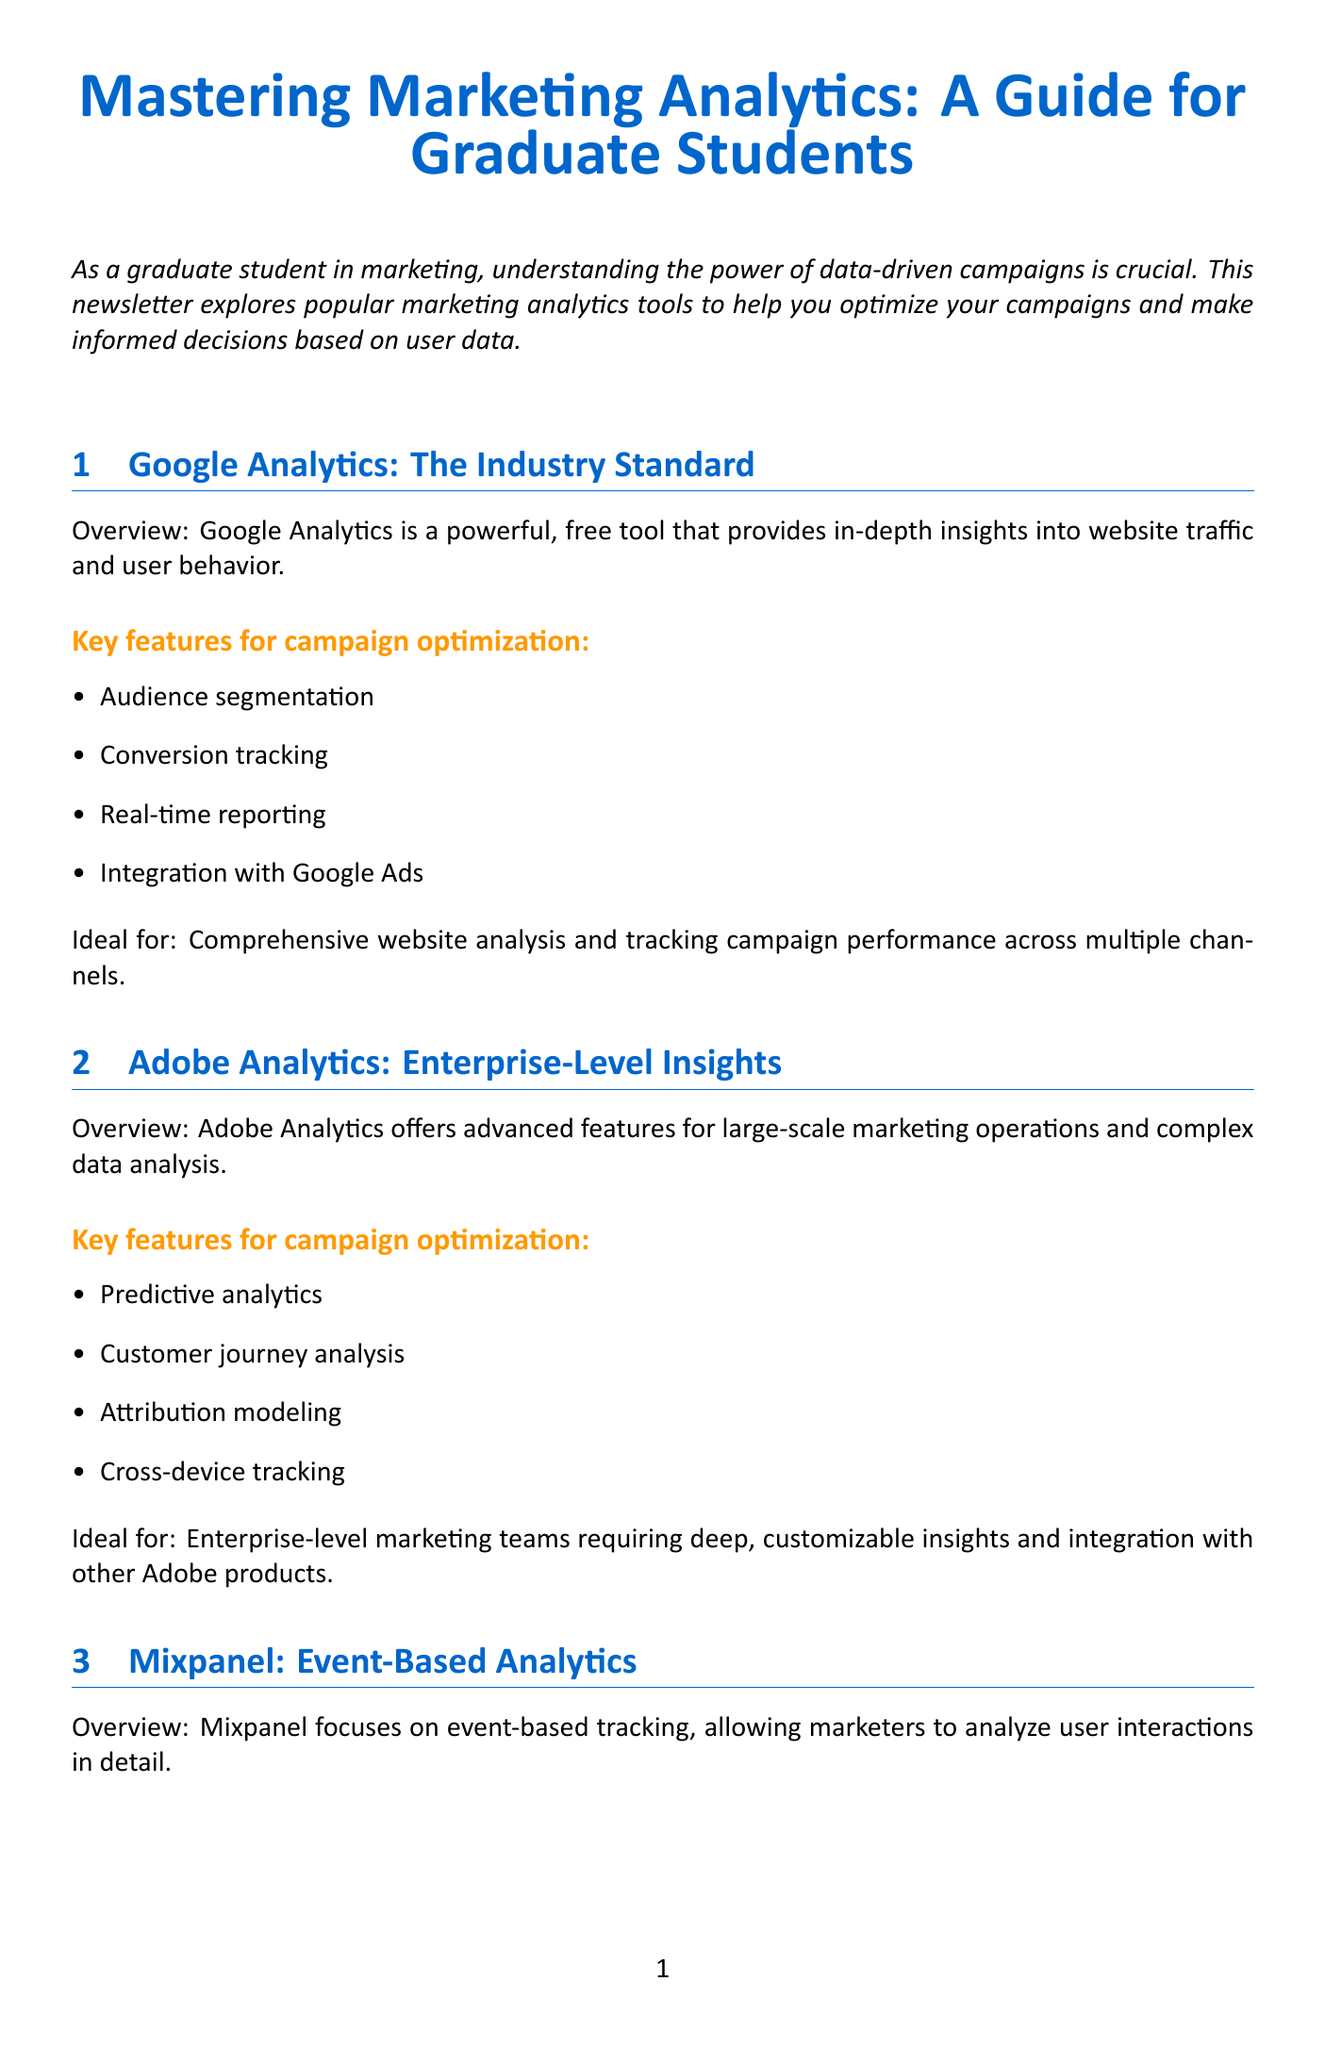What is the title of the newsletter? The title of the newsletter is mentioned at the beginning of the document.
Answer: Mastering Marketing Analytics: A Guide for Graduate Students Which tool is described as the industry standard? The section headers indicate which tool is considered the industry standard in marketing analytics.
Answer: Google Analytics What are the key features of Adobe Analytics for campaign optimization? The section regarding Adobe Analytics lists features relevant to campaign optimization.
Answer: Predictive analytics, Customer journey analysis, Attribution modeling, Cross-device tracking Ideal for which type of businesses is HubSpot Marketing Analytics? The document specifies the target audience for HubSpot Marketing Analytics.
Answer: Small to medium-sized businesses What unique feature does Mixpanel focus on? The overview of Mixpanel highlights its primary focus area in analytics.
Answer: Event-based tracking What kind of analysis does Tableau excel in? The document provides insights into Tableau's strengths in data analysis.
Answer: Data visualization How many tools are compared in the newsletter? Counting the sections in the newsletter reveals the number of tools discussed.
Answer: Five What is the main focus of the newsletter? The introduction outlines the overarching theme and objective of the newsletter.
Answer: Optimizing campaigns using marketing analytics tools 